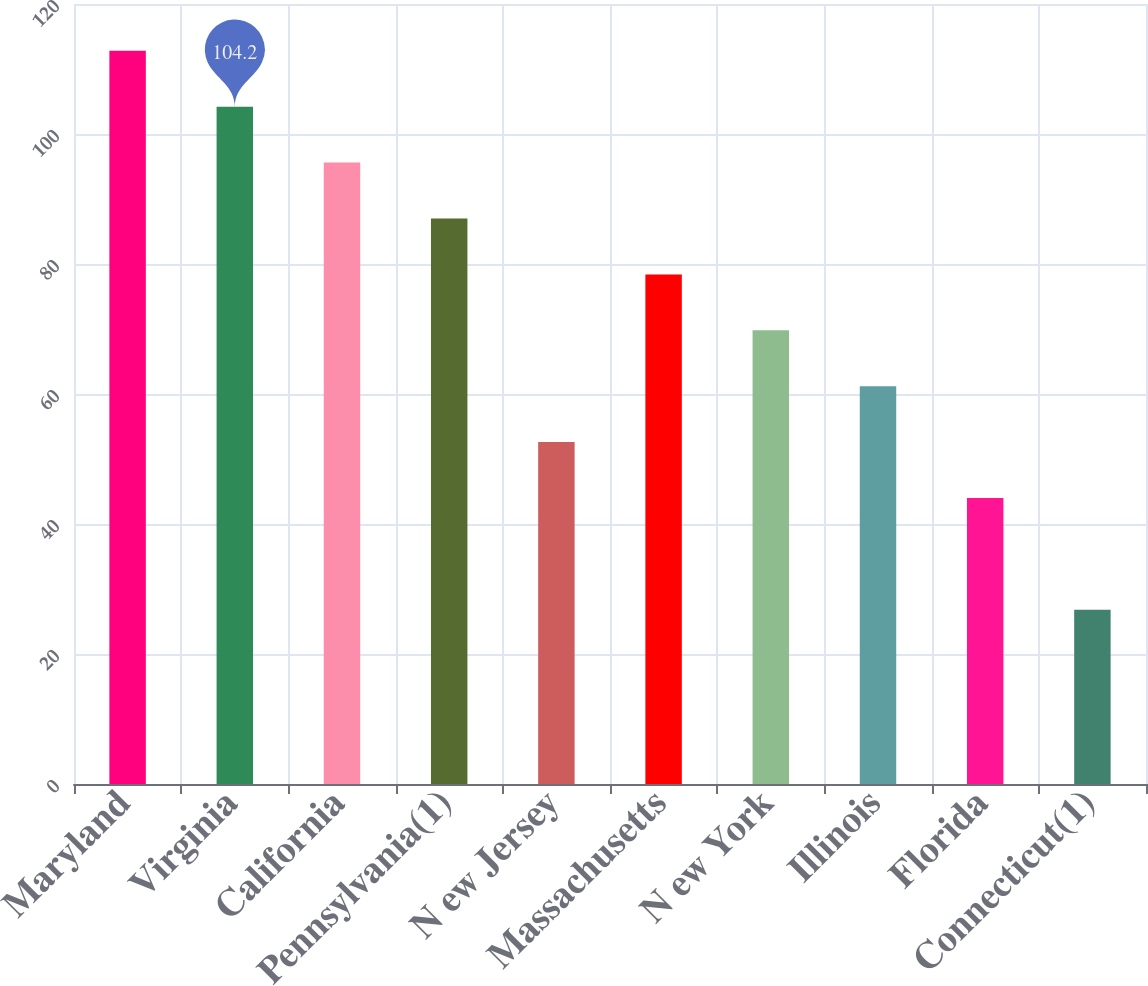<chart> <loc_0><loc_0><loc_500><loc_500><bar_chart><fcel>Maryland<fcel>Virginia<fcel>California<fcel>Pennsylvania(1)<fcel>N ew Jersey<fcel>Massachusetts<fcel>N ew York<fcel>Illinois<fcel>Florida<fcel>Connecticut(1)<nl><fcel>112.8<fcel>104.2<fcel>95.6<fcel>87<fcel>52.6<fcel>78.4<fcel>69.8<fcel>61.2<fcel>44<fcel>26.8<nl></chart> 